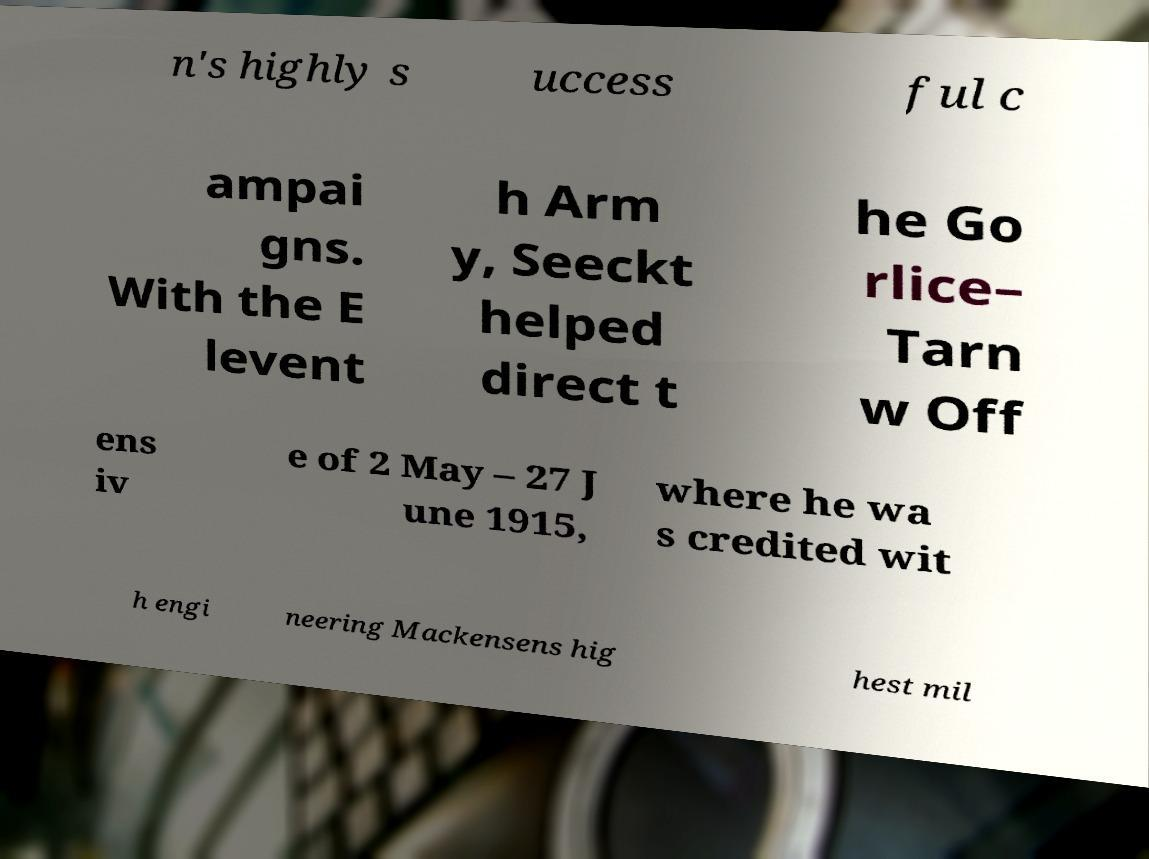Please read and relay the text visible in this image. What does it say? n's highly s uccess ful c ampai gns. With the E levent h Arm y, Seeckt helped direct t he Go rlice– Tarn w Off ens iv e of 2 May – 27 J une 1915, where he wa s credited wit h engi neering Mackensens hig hest mil 